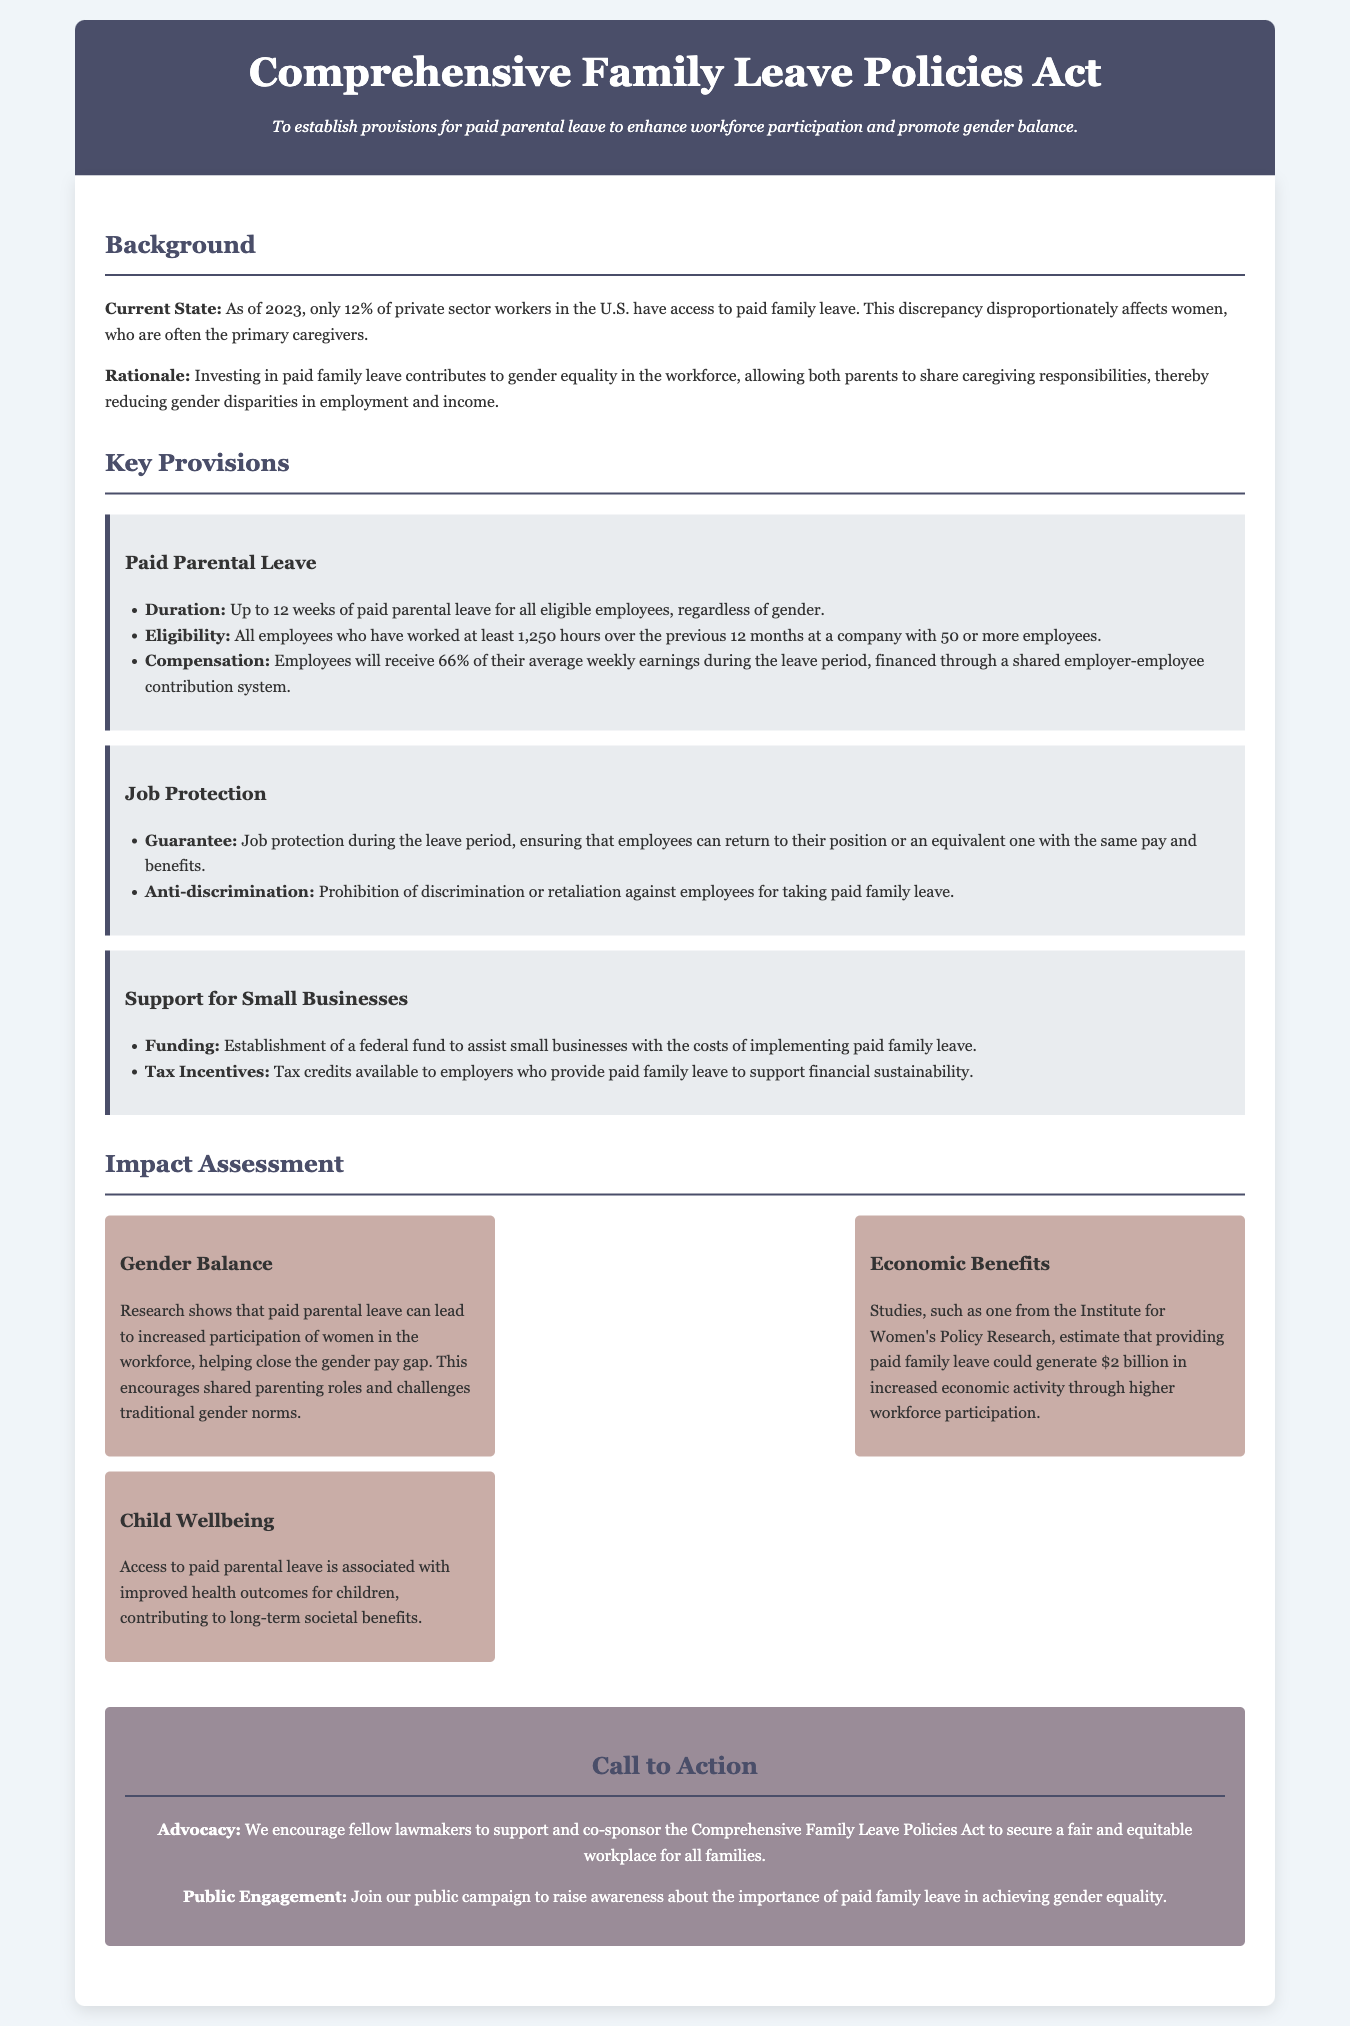What is the duration of paid parental leave? The document states that the duration of paid parental leave is up to 12 weeks for all eligible employees.
Answer: 12 weeks Who is eligible for paid parental leave? Eligibility is defined in the document as all employees who have worked at least 1,250 hours over the previous 12 months at a company with 50 or more employees.
Answer: All employees who have worked 1,250 hours What percentage of average weekly earnings will employees receive during the leave? The document specifies that employees will receive 66% of their average weekly earnings during the leave period.
Answer: 66% What is the economic benefit estimated from providing paid family leave? Research mentioned in the document estimates that providing paid family leave could generate $2 billion in increased economic activity.
Answer: $2 billion What does the job protection provision guarantee? The job protection provision guarantees that employees can return to their position or an equivalent one with the same pay and benefits.
Answer: Job protection guarantee How does paid parental leave impact gender balance in the workforce? The document explains that paid parental leave can increase participation of women in the workforce, helping to close the gender pay gap.
Answer: Increases participation of women What kind of support is offered to small businesses? According to the document, small businesses will receive assistance through a federal fund and tax credits for providing paid family leave.
Answer: Federal fund and tax credits What is the purpose of the Comprehensive Family Leave Policies Act? The purpose is to establish provisions for paid parental leave to enhance workforce participation and promote gender balance.
Answer: Enhance workforce participation and promote gender balance What societal benefit is associated with access to paid parental leave? The document mentions improved health outcomes for children as a long-term societal benefit associated with access to paid parental leave.
Answer: Improved health outcomes for children 